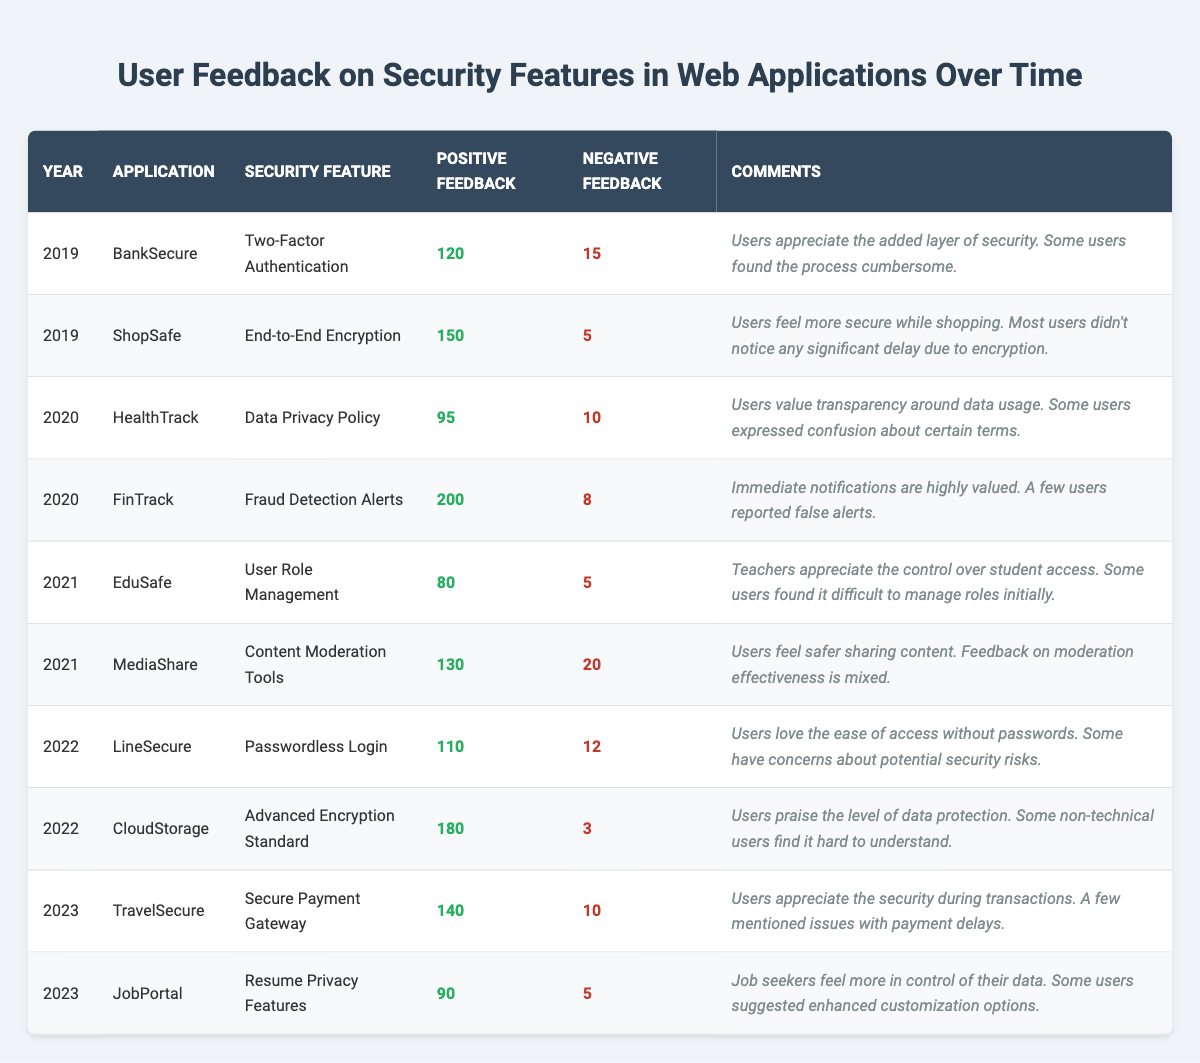What is the total positive feedback for the security features in 2020? The positive feedback for 2020 can be found in two entries: FinTrack (200) and HealthTrack (95). Adding these together, 200 + 95 = 295.
Answer: 295 Which security feature received the most negative feedback in 2021? In 2021, MediaShare received 20 negative feedbacks while EduSafe received only 5. Therefore, MediaShare had the most negative feedback.
Answer: MediaShare What percentage of the feedback for BankSecure in 2019 was negative? For BankSecure, there were 120 positive and 15 negative feedbacks. The total feedback is 120 + 15 = 135. The percentage of negative feedback is (15/135) * 100 = 11.11%.
Answer: 11.11% Which application received the highest positive feedback overall? The entries with positive feedback are: FinTrack (200), CloudStorage (180), and ShopSafe (150). FinTrack has the highest positive feedback with 200.
Answer: FinTrack What is the average positive feedback for applications in 2022? The positive feedback for 2022 is: LineSecure (110) and CloudStorage (180). The average is (110 + 180) / 2 = 145.
Answer: 145 Was there any security feature that received only negative comments during the years surveyed? No security feature has zero positive feedback in the table entries; each feature has positive feedback ranging from 80 to 200. Therefore, no feature received only negative comments.
Answer: No How much more positive feedback did FinTrack receive compared to HealthTrack in 2020? In 2020, FinTrack received 200 positive feedback while HealthTrack received 95. The difference is 200 - 95 = 105.
Answer: 105 Which year had the lowest total feedback (positive + negative) combined? Adding the total feedback for each year: 2019 (120 + 15 + 150 + 5) = 290, 2020 (95 + 10 + 200 + 8) = 313, 2021 (80 + 5 + 130 + 20) = 235, 2022 (110 + 12 + 180 + 3) = 305, 2023 (140 + 10 + 90 + 5) = 245. The lowest total is in 2021 with 235.
Answer: 2021 What was the trend in user feedback for security features from 2019 to 2023? By analyzing the total positive feedback year by year: 2019 (270), 2020 (295), 2021 (210), 2022 (290), and 2023 (230). The trend shows an initial increase, then a decrease in 2021, followed by fluctuations in subsequent years.
Answer: Mixed trend What proportion of feedback in 2023 was positive for TravelSecure? TravelSecure received 140 positive and 10 negative feedbacks in 2023. Therefore, the proportion of positive feedback is 140 / (140 + 10) = 140 / 150 = 0.9333 or approximately 93.33%.
Answer: 93.33% 